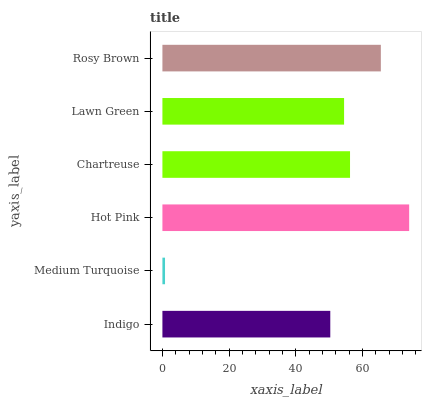Is Medium Turquoise the minimum?
Answer yes or no. Yes. Is Hot Pink the maximum?
Answer yes or no. Yes. Is Hot Pink the minimum?
Answer yes or no. No. Is Medium Turquoise the maximum?
Answer yes or no. No. Is Hot Pink greater than Medium Turquoise?
Answer yes or no. Yes. Is Medium Turquoise less than Hot Pink?
Answer yes or no. Yes. Is Medium Turquoise greater than Hot Pink?
Answer yes or no. No. Is Hot Pink less than Medium Turquoise?
Answer yes or no. No. Is Chartreuse the high median?
Answer yes or no. Yes. Is Lawn Green the low median?
Answer yes or no. Yes. Is Lawn Green the high median?
Answer yes or no. No. Is Medium Turquoise the low median?
Answer yes or no. No. 